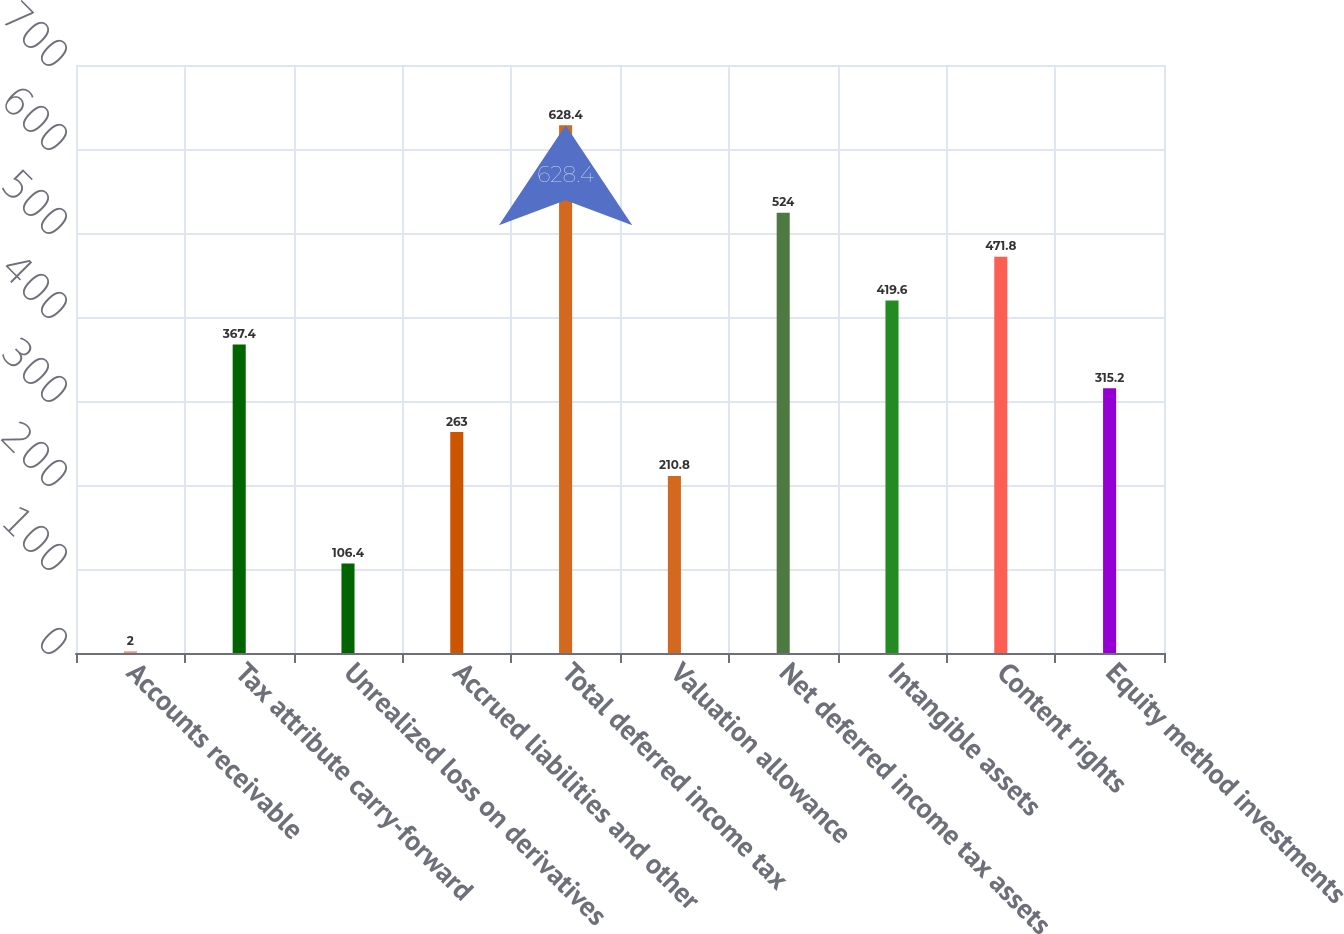<chart> <loc_0><loc_0><loc_500><loc_500><bar_chart><fcel>Accounts receivable<fcel>Tax attribute carry-forward<fcel>Unrealized loss on derivatives<fcel>Accrued liabilities and other<fcel>Total deferred income tax<fcel>Valuation allowance<fcel>Net deferred income tax assets<fcel>Intangible assets<fcel>Content rights<fcel>Equity method investments<nl><fcel>2<fcel>367.4<fcel>106.4<fcel>263<fcel>628.4<fcel>210.8<fcel>524<fcel>419.6<fcel>471.8<fcel>315.2<nl></chart> 